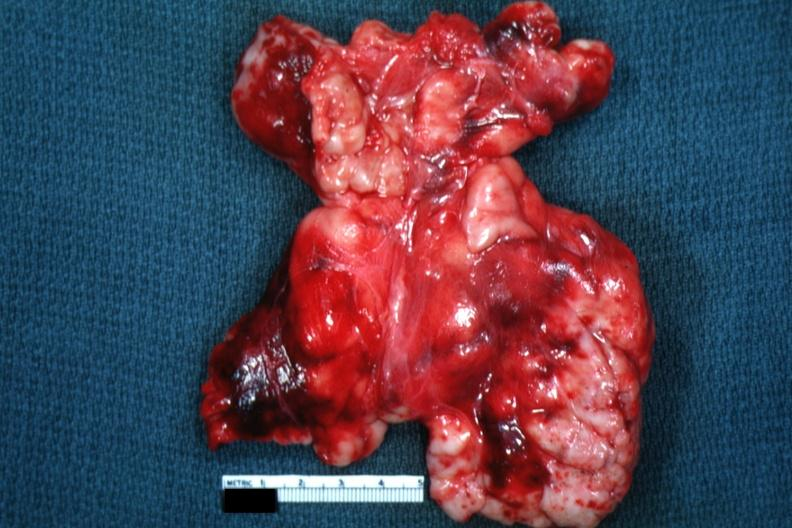how does this image appear as large mass of matted nodes like lymphoma?
Answer the question using a single word or phrase. Malignant 